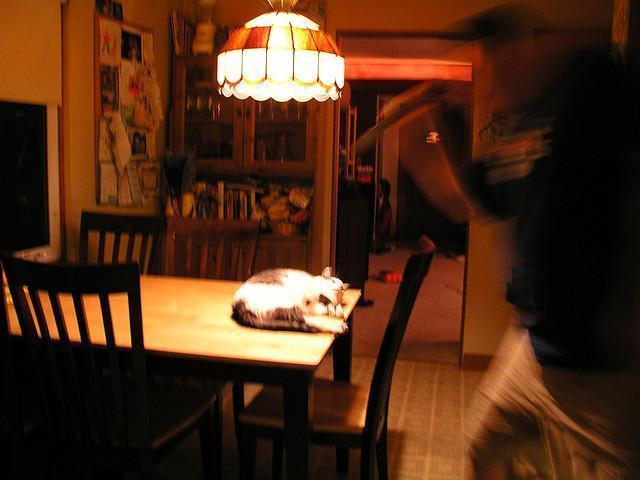How many chairs can you see?
Give a very brief answer. 4. How many dogs are playing in the ocean?
Give a very brief answer. 0. 